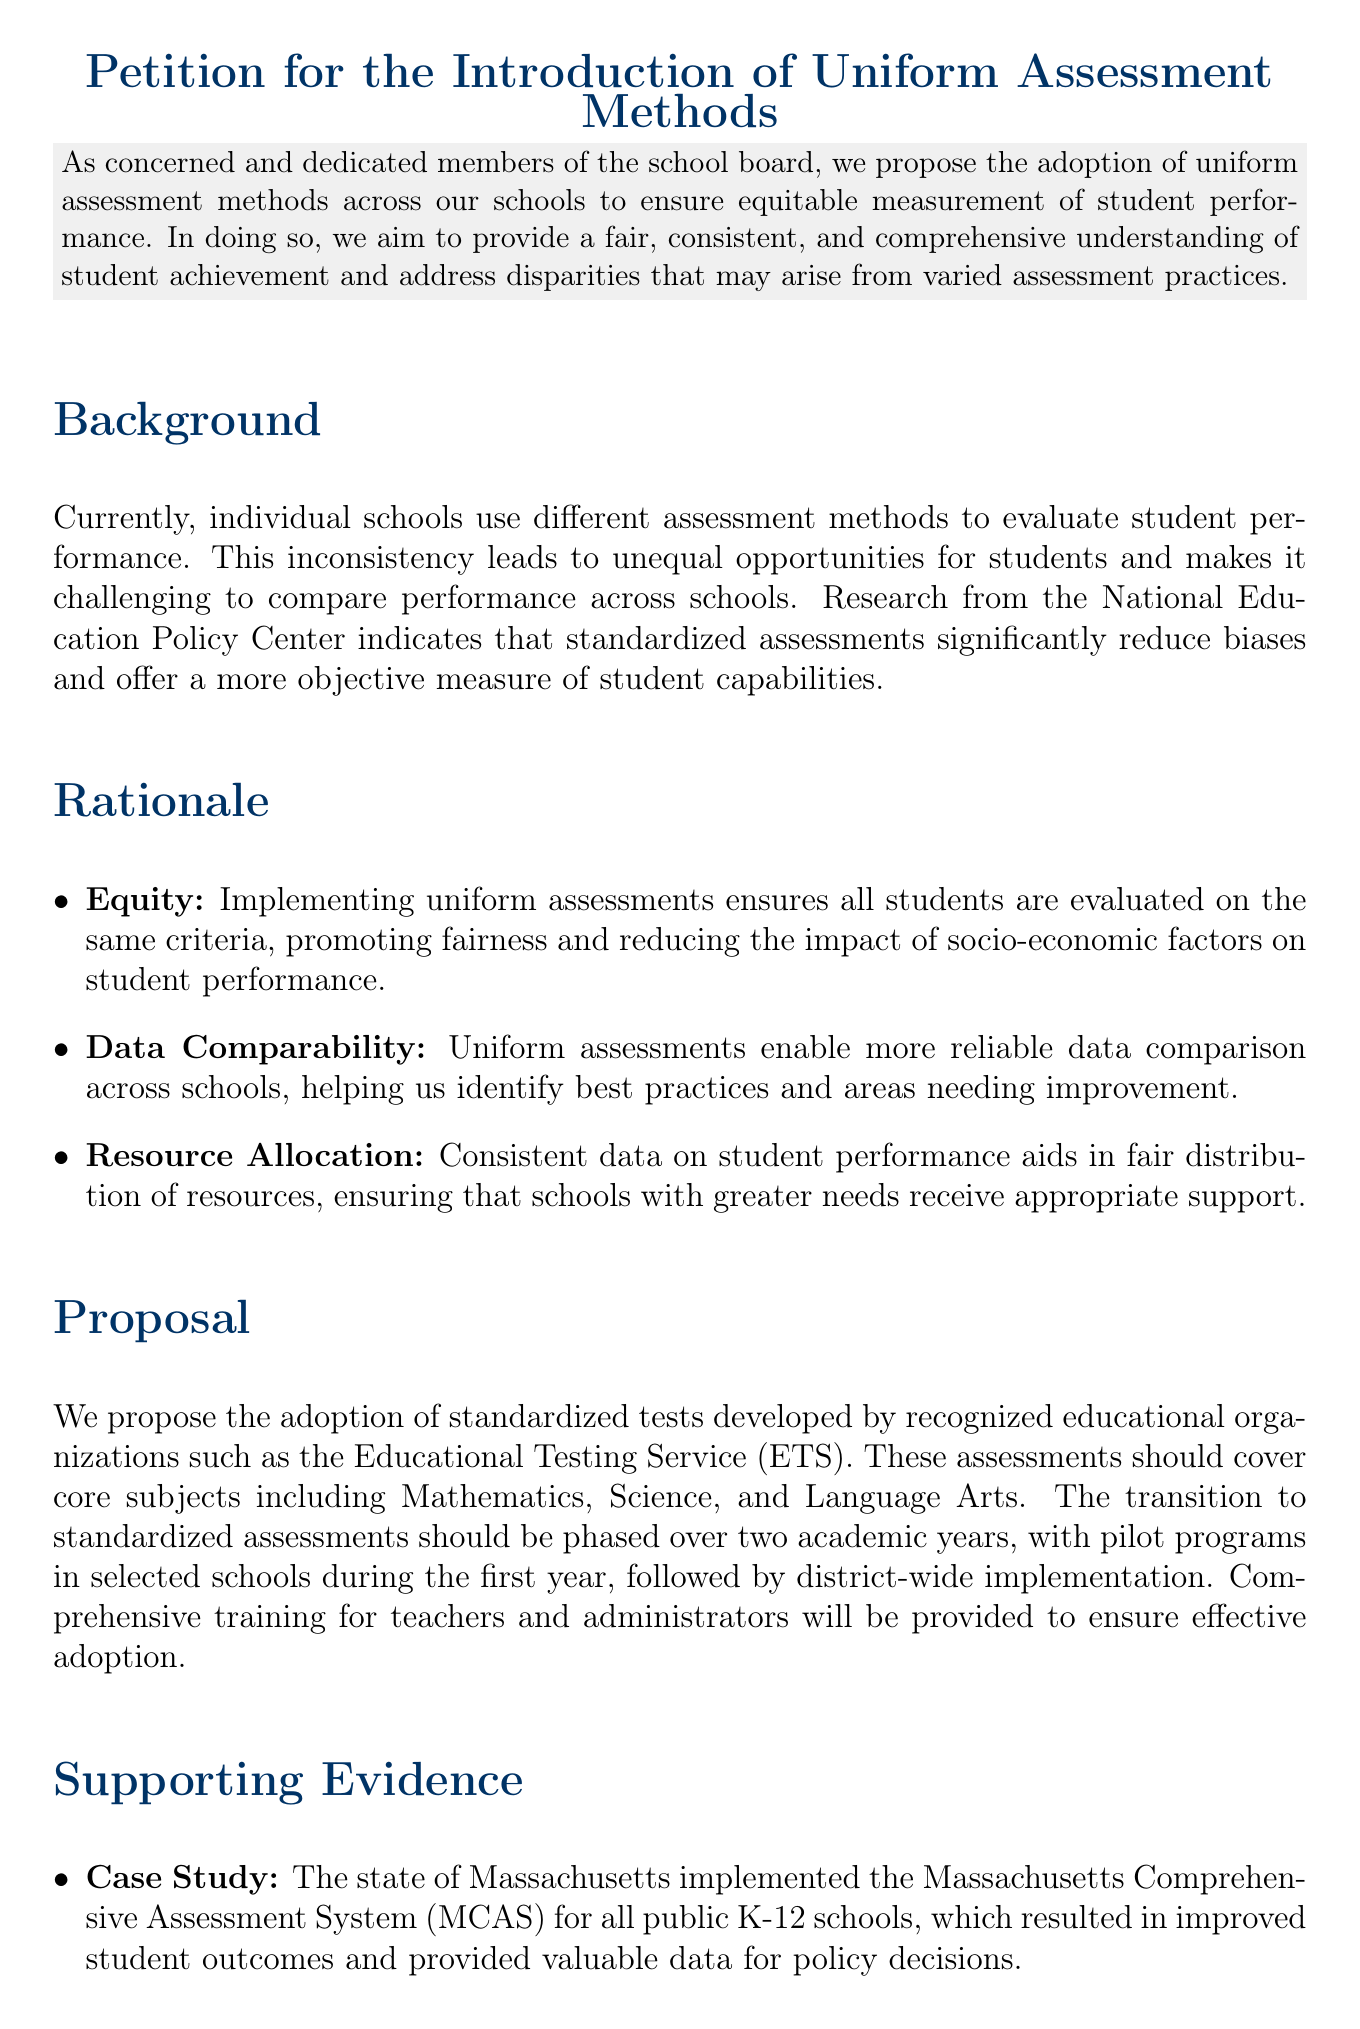What is the title of the petition? The title of the petition is explicitly mentioned at the beginning of the document.
Answer: Petition for the Introduction of Uniform Assessment Methods What is the primary concern addressed in the petition? The primary concern is the inconsistency in assessment methods across schools that affects student performance evaluation.
Answer: Inconsistent assessment methods What organization is proposed to develop standardized tests? The document mentions an organization recognized for educational assessments.
Answer: Educational Testing Service (ETS) How long is the proposed transition to standardized assessments? The document specifies the time frame for the transition to standardized assessments.
Answer: Two academic years What subject areas will the standardized assessments cover? The petition outlines the core subjects included in the proposal for standardized assessments.
Answer: Mathematics, Science, and Language Arts What potential benefit is highlighted regarding resource allocation? The document discusses the advantage of consistent data in the fair distribution of resources across schools.
Answer: Fair distribution of resources Which state's assessment system is referenced as a case study? The document provides an example of a state's standardized assessment system to support its argument.
Answer: Massachusetts What is one expert's opinion included in the supporting evidence? The petition cites an opinion on the importance of standardized assessments for educational equity.
Answer: "Standardized assessments... can provide critical insights into student learning" What is the final call to action in the conclusion? The petition concludes with an appeal directed towards the school board regarding the petition.
Answer: Urge the school board to consider this petition favorably 